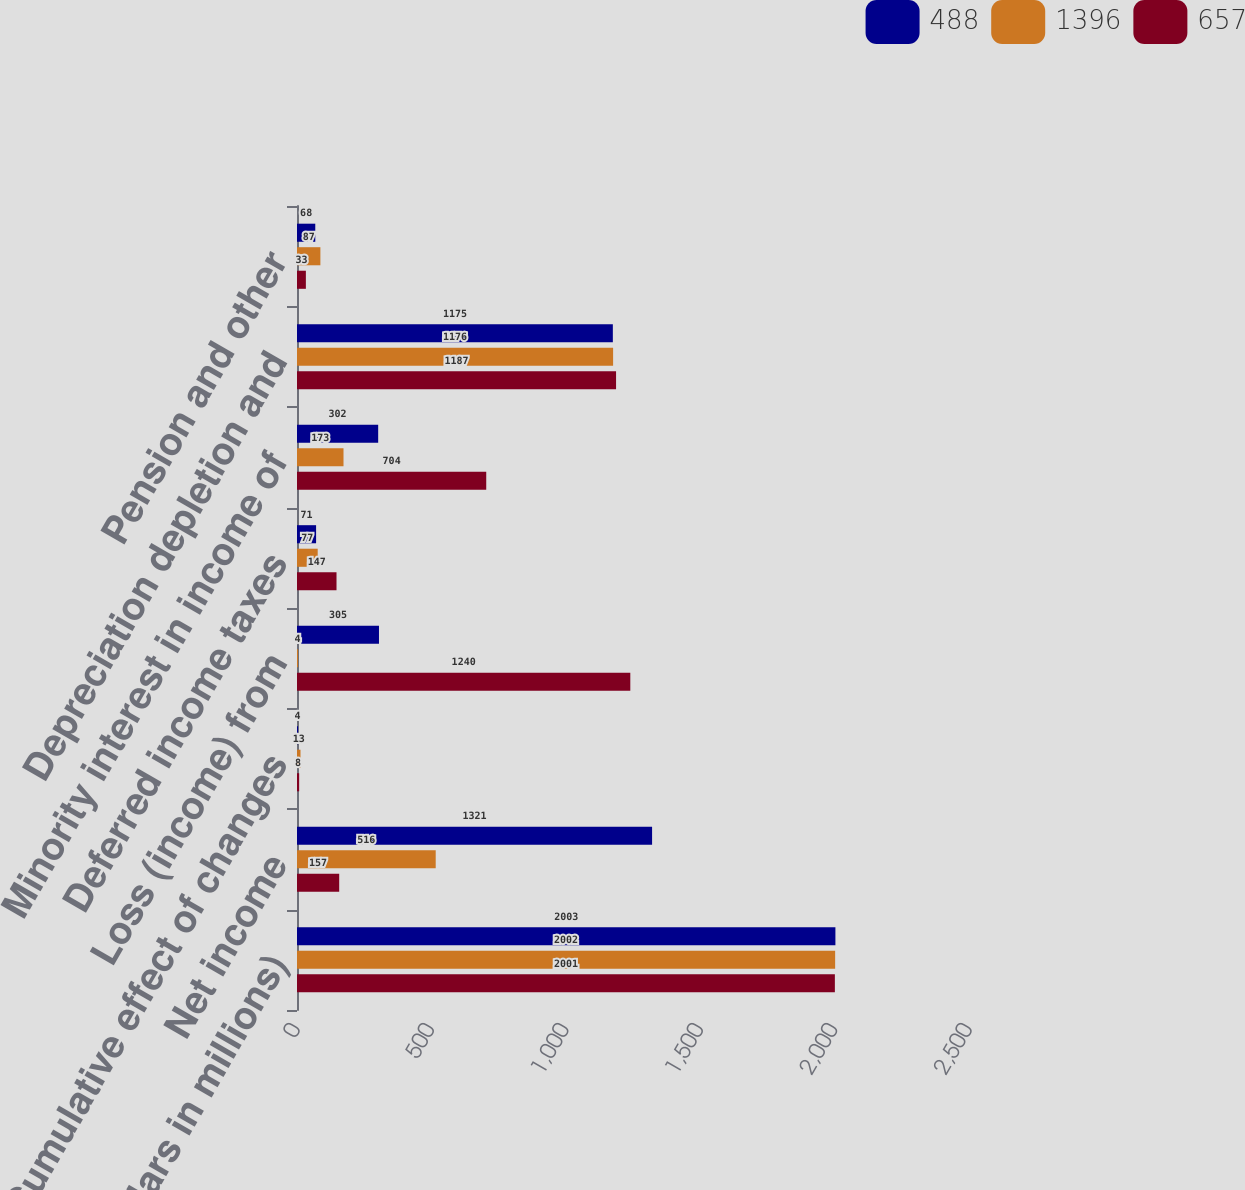Convert chart. <chart><loc_0><loc_0><loc_500><loc_500><stacked_bar_chart><ecel><fcel>(Dollars in millions)<fcel>Net income<fcel>Cumulative effect of changes<fcel>Loss (income) from<fcel>Deferred income taxes<fcel>Minority interest in income of<fcel>Depreciation depletion and<fcel>Pension and other<nl><fcel>488<fcel>2003<fcel>1321<fcel>4<fcel>305<fcel>71<fcel>302<fcel>1175<fcel>68<nl><fcel>1396<fcel>2002<fcel>516<fcel>13<fcel>4<fcel>77<fcel>173<fcel>1176<fcel>87<nl><fcel>657<fcel>2001<fcel>157<fcel>8<fcel>1240<fcel>147<fcel>704<fcel>1187<fcel>33<nl></chart> 